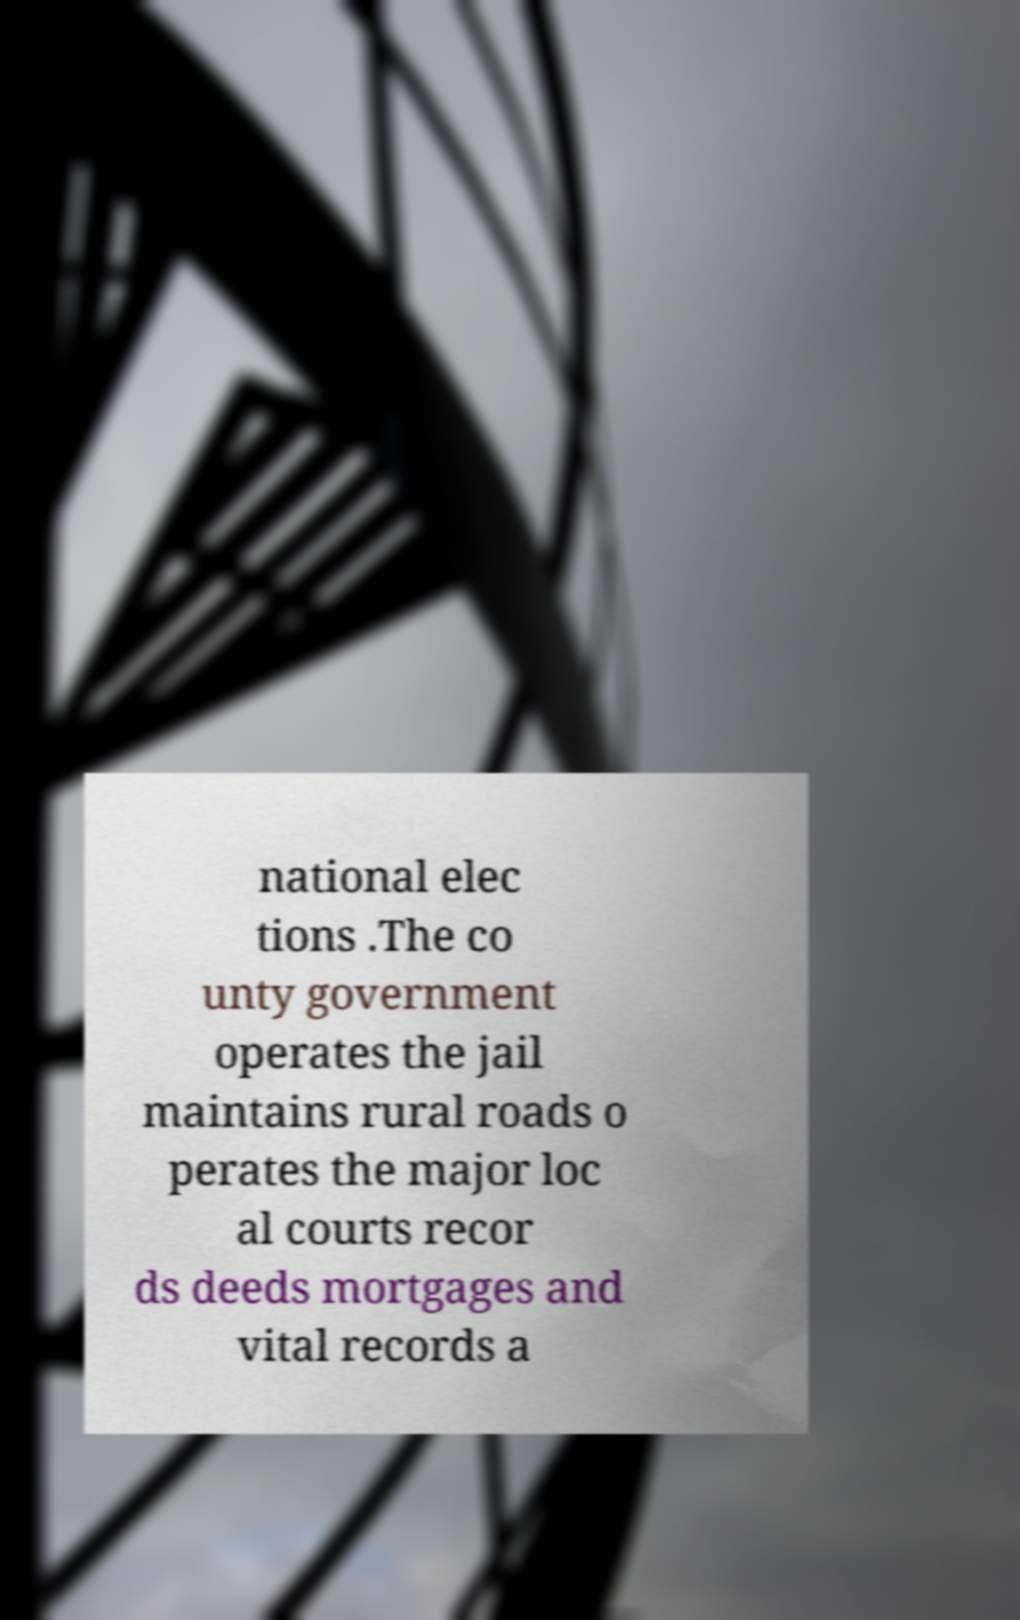Could you extract and type out the text from this image? national elec tions .The co unty government operates the jail maintains rural roads o perates the major loc al courts recor ds deeds mortgages and vital records a 